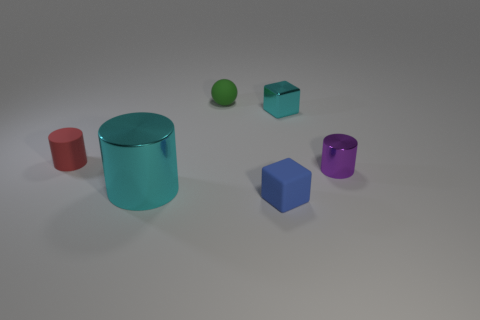Subtract all metal cylinders. How many cylinders are left? 1 Add 2 large cyan shiny cylinders. How many objects exist? 8 Subtract all blocks. How many objects are left? 4 Add 6 matte cylinders. How many matte cylinders are left? 7 Add 1 large cyan metallic things. How many large cyan metallic things exist? 2 Subtract 0 brown spheres. How many objects are left? 6 Subtract all small matte spheres. Subtract all big cyan shiny things. How many objects are left? 4 